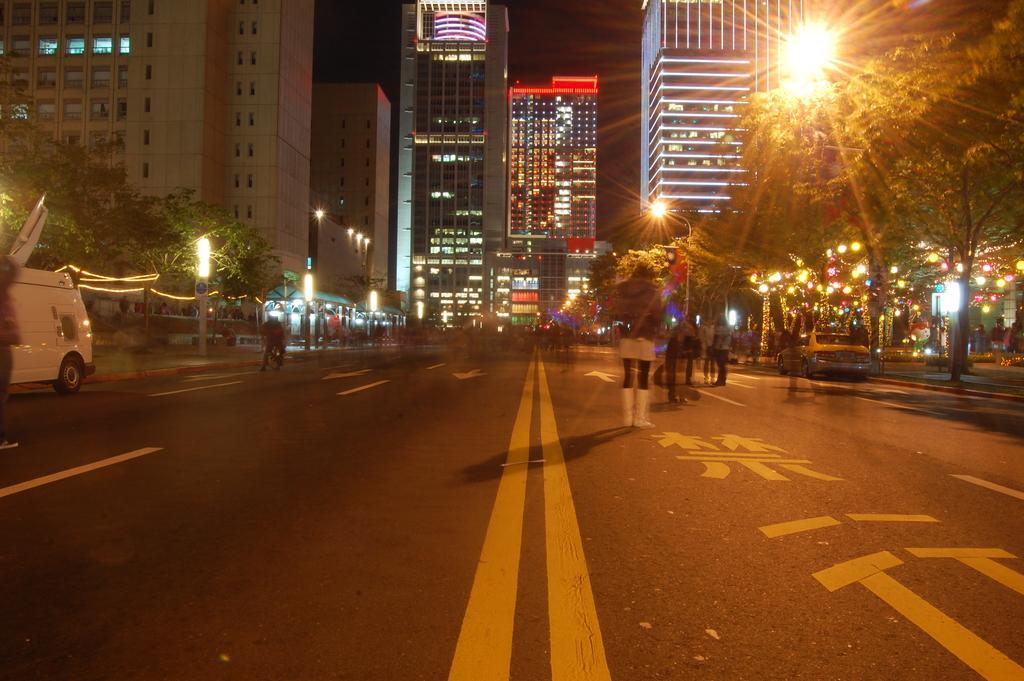In one or two sentences, can you explain what this image depicts? In this image there is a road, on that road there are vehicles and there are people, on either side of the road there are light poles, trees, in the background there are buildings. 